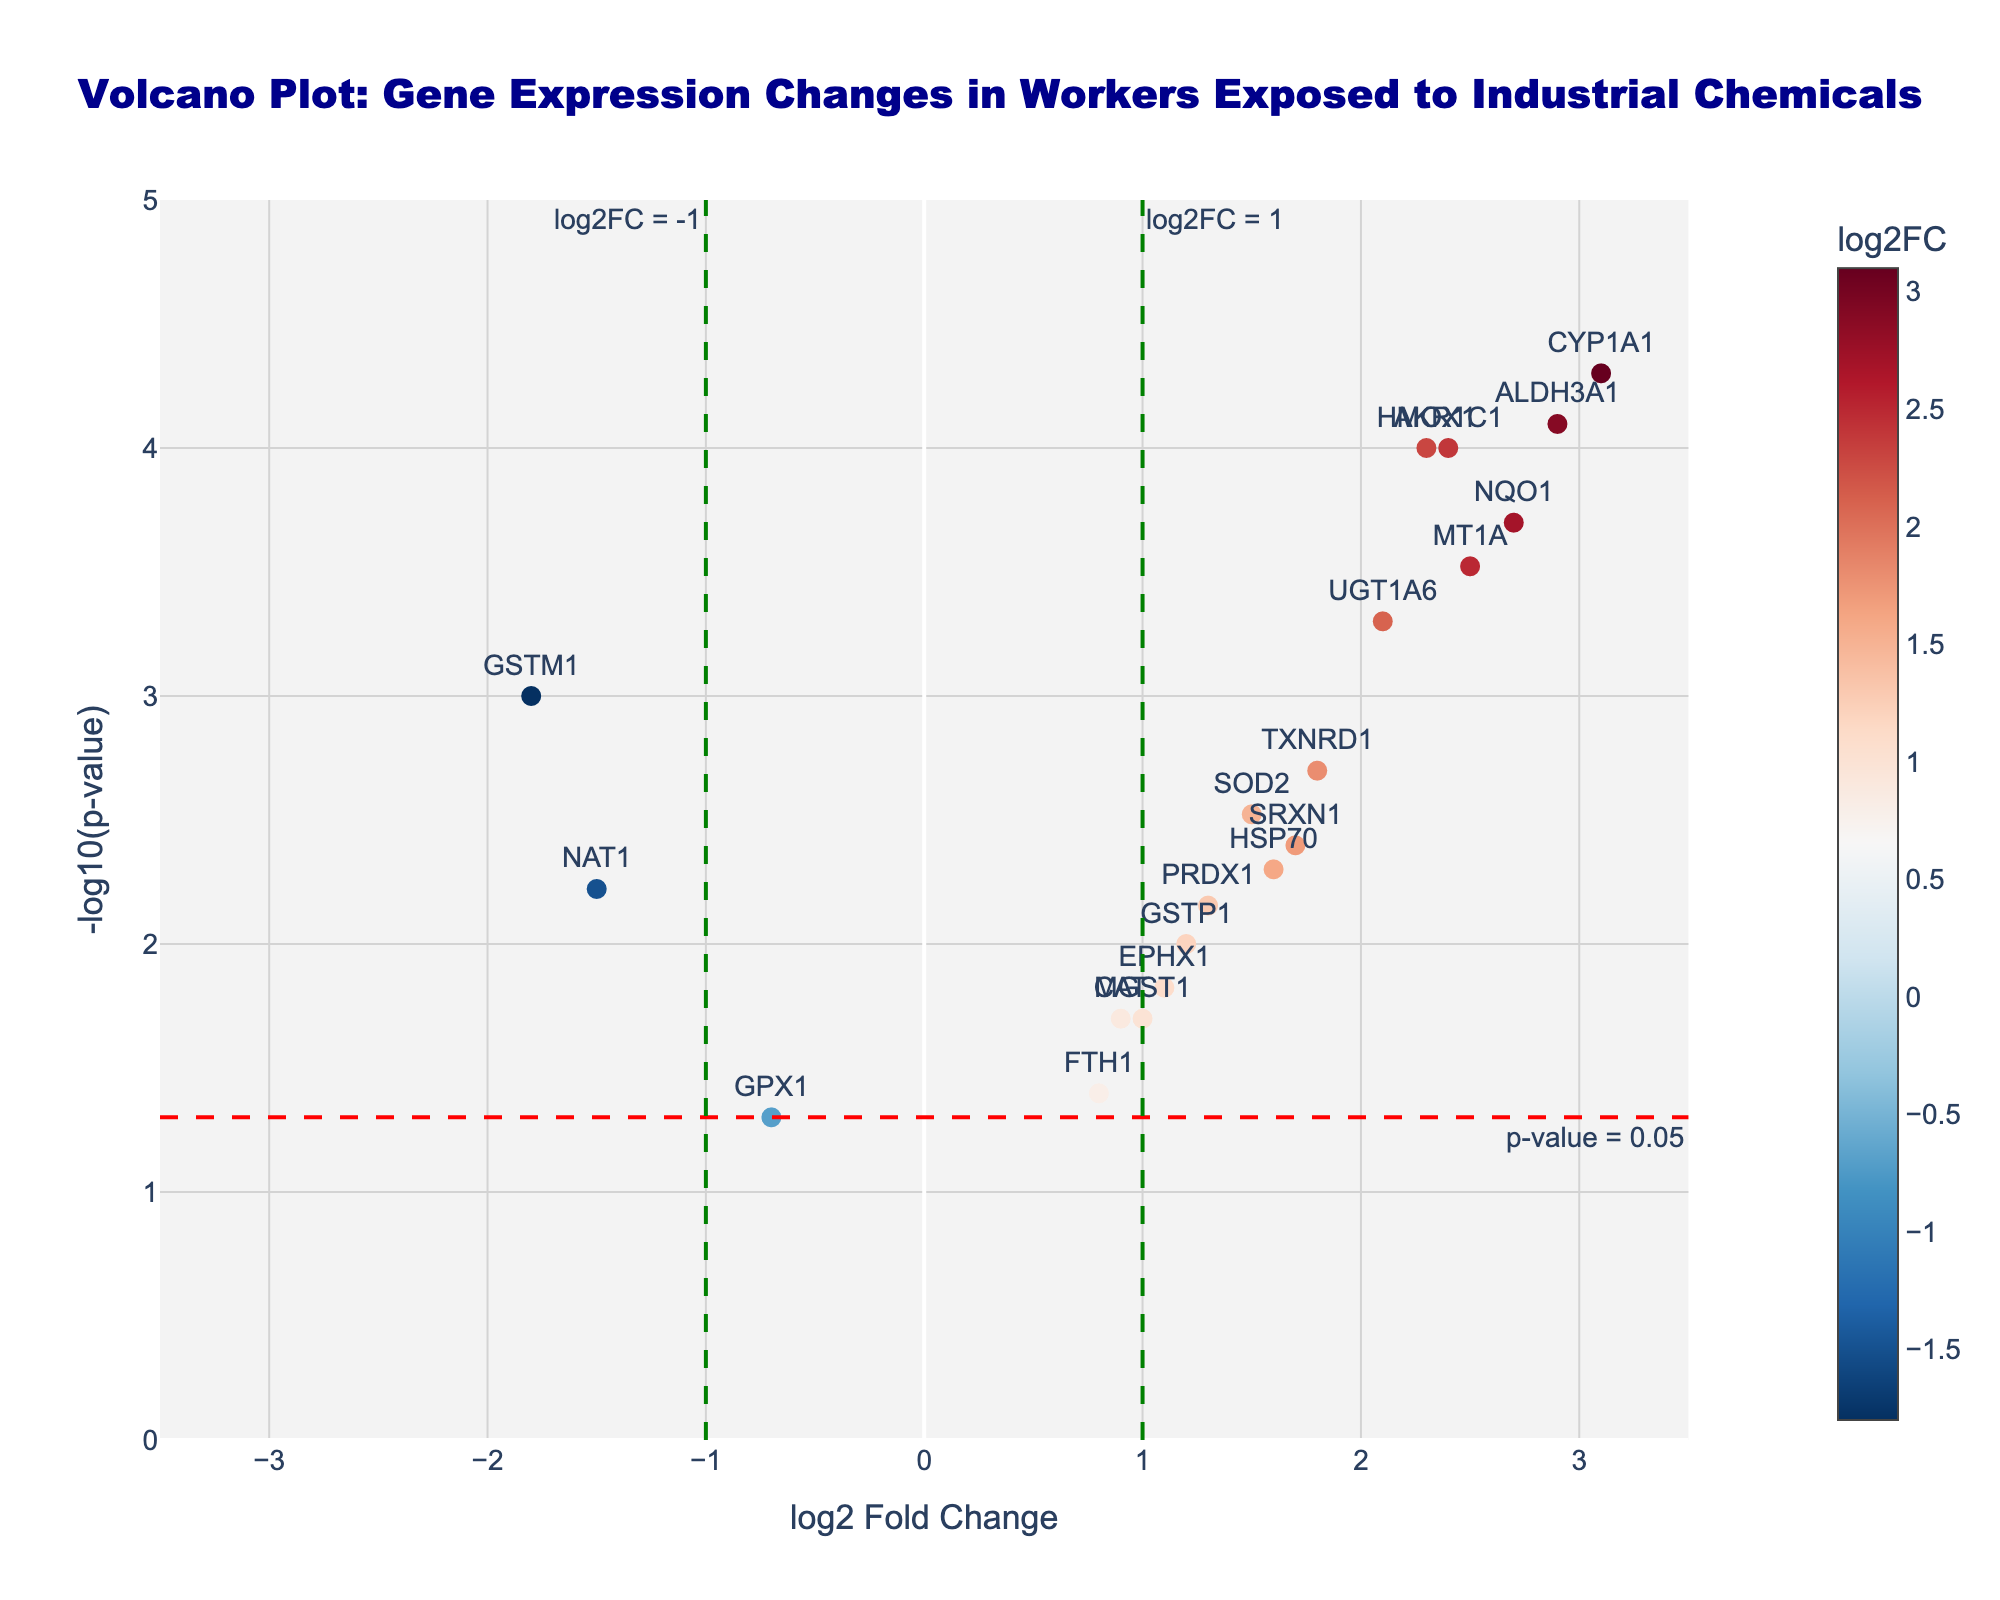What is the title of the plot? The title of the plot is shown at the top and is often the most prominent text. Here, it states "Volcano Plot: Gene Expression Changes in Workers Exposed to Industrial Chemicals."
Answer: "Volcano Plot: Gene Expression Changes in Workers Exposed to Industrial Chemicals" What do the x-axis and y-axis represent? The x-axis represents the log2 fold change of gene expression, indicating how much each gene's expression has increased or decreased. The y-axis represents the -log10(p-value), indicating the significance of the gene expression changes.
Answer: x-axis: log2 Fold Change, y-axis: -log10(p-value) How many genes have a significant p-value (p < 0.05)? To find the number of genes with a p-value less than 0.05, we look for points above the dashed red horizontal line. Each point represents a gene, and the ones above this threshold are significant.
Answer: 14 Which gene has the highest log2 fold change? The gene with the highest log2 fold change is at the far right of the plot. By checking the gene labels, we see that CYP1A1 has the highest log2 fold change.
Answer: CYP1A1 Which gene has the most negative log2 fold change? The gene with the most negative log2 fold change is at the far left of the plot. By checking the gene labels, we see that GSTM1 has the most negative log2 fold change.
Answer: GSTM1 Are there any genes that are both highly significant (p < 0.001) and have a high fold change (log2FC > 2)? To answer this, look for points above -log10(p-value) = 3 and to the right of log2FC = 2. CYP1A1, ALDH3A1, and NQO1 meet these criteria.
Answer: CYP1A1, ALDH3A1, NQO1 Which gene has a log2 fold change of approximately 1.2 and a p-value less than 0.01? Locate the gene nearest to x = 1.2 and above the dashed red line for p-value < 0.01. The gene GSTP1 fits these criteria.
Answer: GSTP1 What is the p-value of the gene with the highest -log10(p-value)? The highest -log10(p-value) can be found at the topmost point of the plot. This gene is CYP1A1. By referring to the hover text or data table, the p-value is 0.00005.
Answer: 0.00005 Between HMOX1 and HSP70, which gene has a more significant p-value and by what factor difference? HMOX1 and HSP70 both have labels. To compare, we check their -log10(p-value) values. HMOX1 is around 4, and HSP70 is around 2.7. Factor difference is calculated as: 10^4 / 10^2.7.
Answer: HMOX1, approximately 20 times more significant 